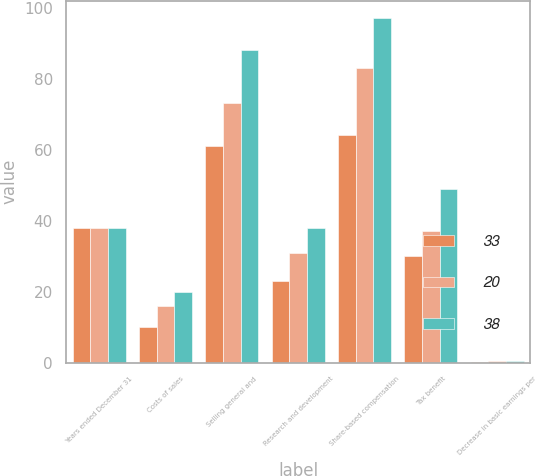Convert chart. <chart><loc_0><loc_0><loc_500><loc_500><stacked_bar_chart><ecel><fcel>Years ended December 31<fcel>Costs of sales<fcel>Selling general and<fcel>Research and development<fcel>Share-based compensation<fcel>Tax benefit<fcel>Decrease in basic earnings per<nl><fcel>33<fcel>38<fcel>10<fcel>61<fcel>23<fcel>64<fcel>30<fcel>0.28<nl><fcel>20<fcel>38<fcel>16<fcel>73<fcel>31<fcel>83<fcel>37<fcel>0.31<nl><fcel>38<fcel>38<fcel>20<fcel>88<fcel>38<fcel>97<fcel>49<fcel>0.33<nl></chart> 